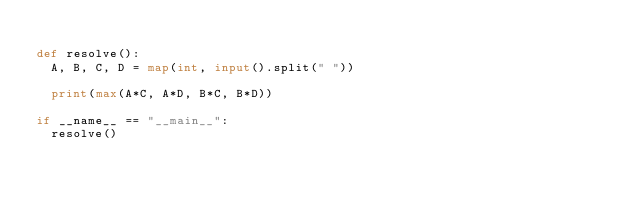<code> <loc_0><loc_0><loc_500><loc_500><_Python_>
def resolve():
  A, B, C, D = map(int, input().split(" "))

  print(max(A*C, A*D, B*C, B*D))

if __name__ == "__main__":
  resolve()</code> 